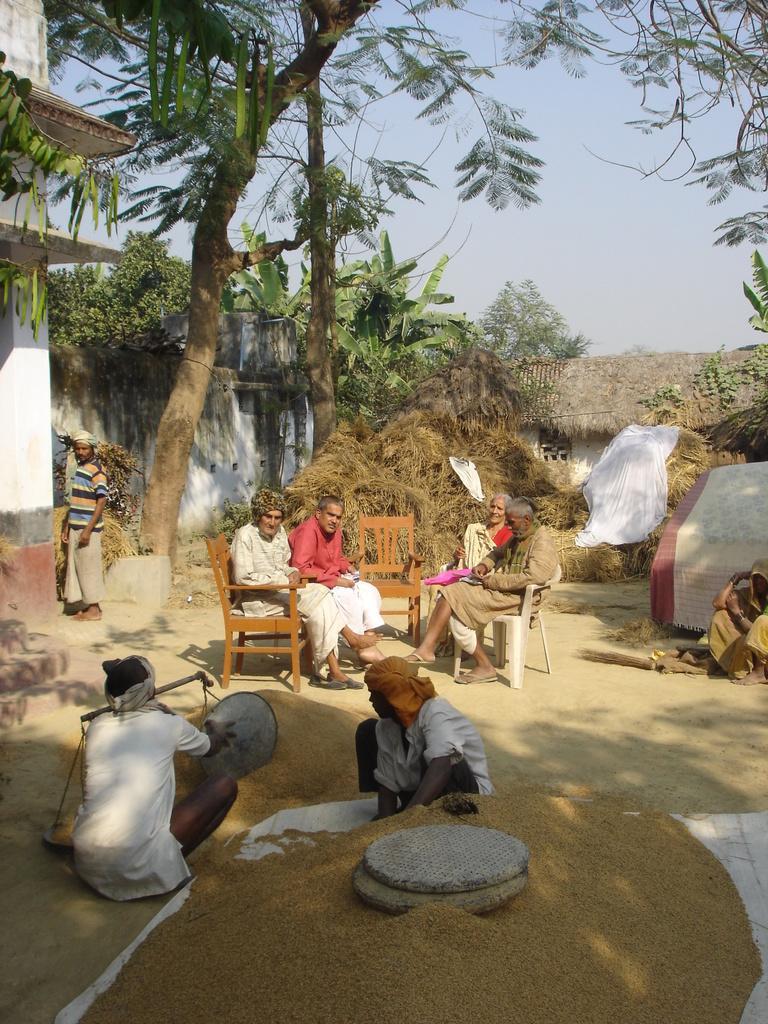Describe this image in one or two sentences. In this picture we can see a group of people on the ground and in the background we can see trees,sky. 